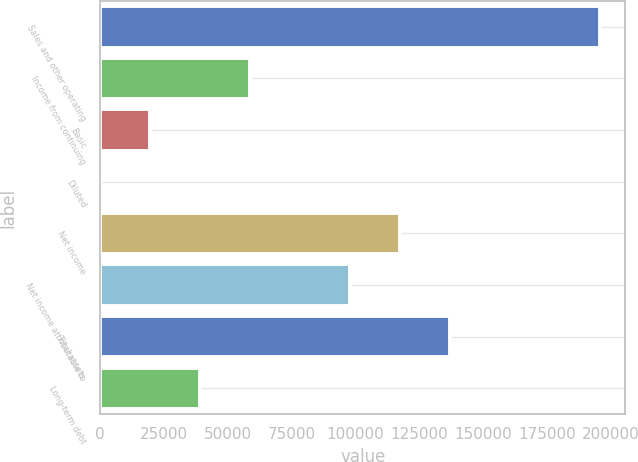Convert chart to OTSL. <chart><loc_0><loc_0><loc_500><loc_500><bar_chart><fcel>Sales and other operating<fcel>Income from continuing<fcel>Basic<fcel>Diluted<fcel>Net income<fcel>Net income attributable to<fcel>Total assets<fcel>Long-term debt<nl><fcel>195931<fcel>58784.5<fcel>19599.8<fcel>7.45<fcel>117562<fcel>97969.2<fcel>137154<fcel>39192.2<nl></chart> 